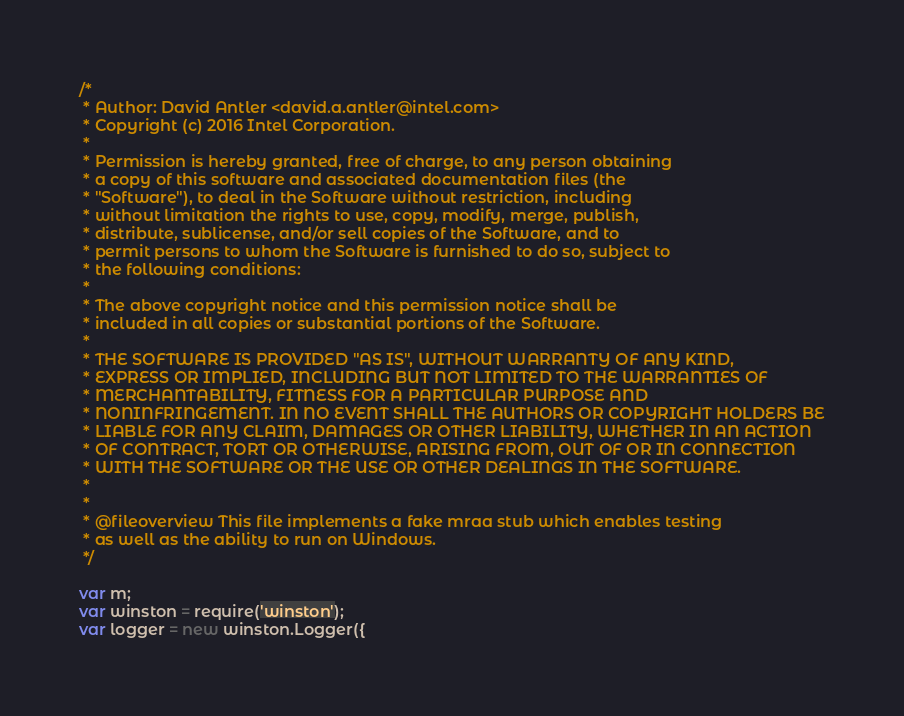Convert code to text. <code><loc_0><loc_0><loc_500><loc_500><_JavaScript_>/*
 * Author: David Antler <david.a.antler@intel.com>
 * Copyright (c) 2016 Intel Corporation.
 *
 * Permission is hereby granted, free of charge, to any person obtaining
 * a copy of this software and associated documentation files (the
 * "Software"), to deal in the Software without restriction, including
 * without limitation the rights to use, copy, modify, merge, publish,
 * distribute, sublicense, and/or sell copies of the Software, and to
 * permit persons to whom the Software is furnished to do so, subject to
 * the following conditions:
 *
 * The above copyright notice and this permission notice shall be
 * included in all copies or substantial portions of the Software.
 *
 * THE SOFTWARE IS PROVIDED "AS IS", WITHOUT WARRANTY OF ANY KIND,
 * EXPRESS OR IMPLIED, INCLUDING BUT NOT LIMITED TO THE WARRANTIES OF
 * MERCHANTABILITY, FITNESS FOR A PARTICULAR PURPOSE AND
 * NONINFRINGEMENT. IN NO EVENT SHALL THE AUTHORS OR COPYRIGHT HOLDERS BE
 * LIABLE FOR ANY CLAIM, DAMAGES OR OTHER LIABILITY, WHETHER IN AN ACTION
 * OF CONTRACT, TORT OR OTHERWISE, ARISING FROM, OUT OF OR IN CONNECTION
 * WITH THE SOFTWARE OR THE USE OR OTHER DEALINGS IN THE SOFTWARE.
 *
 *
 * @fileoverview This file implements a fake mraa stub which enables testing
 * as well as the ability to run on Windows.
 */

var m;
var winston = require('winston');
var logger = new winston.Logger({</code> 